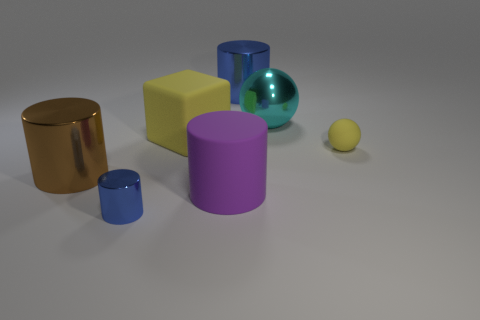Subtract all small blue cylinders. How many cylinders are left? 3 Add 2 big cyan objects. How many objects exist? 9 Subtract 1 balls. How many balls are left? 1 Subtract all purple cylinders. How many cylinders are left? 3 Subtract all balls. How many objects are left? 5 Subtract all blue cylinders. Subtract all cyan blocks. How many cylinders are left? 2 Subtract all purple spheres. How many purple cylinders are left? 1 Subtract all small rubber cylinders. Subtract all blocks. How many objects are left? 6 Add 4 small blue metal things. How many small blue metal things are left? 5 Add 4 blue objects. How many blue objects exist? 6 